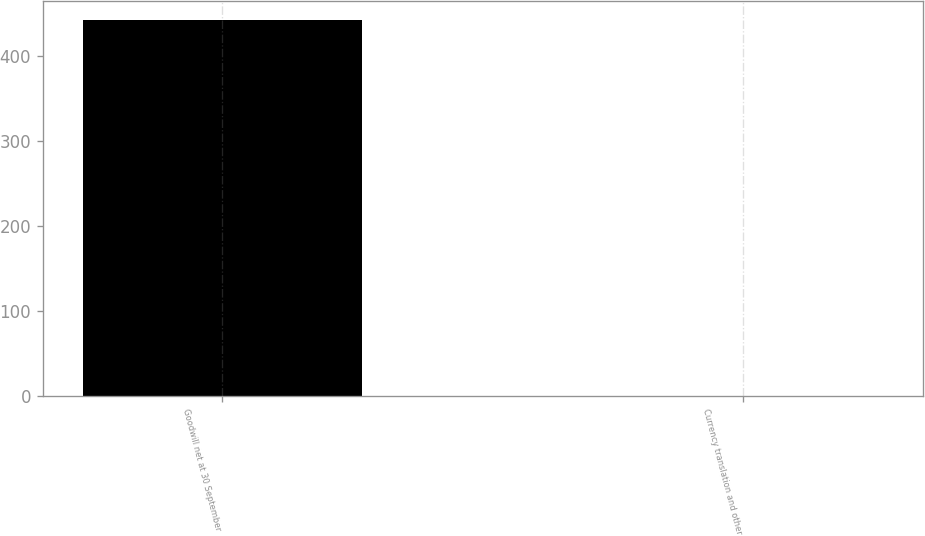Convert chart to OTSL. <chart><loc_0><loc_0><loc_500><loc_500><bar_chart><fcel>Goodwill net at 30 September<fcel>Currency translation and other<nl><fcel>442.8<fcel>0.5<nl></chart> 